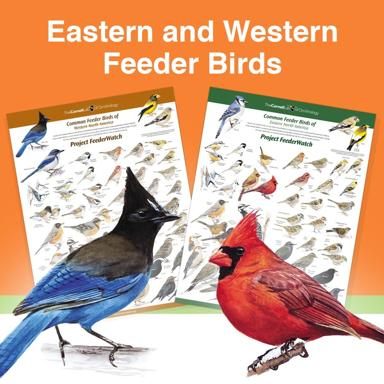How can I differentiate between Eastern and Western feeder birds? One way to differentiate between Eastern and Western feeder birds is by looking at their colors, patterns, and physical features. Since the image displays two different bird posters, you can compare and contrast the birds' appearances to identify differences according to their geographic regions. Keep in mind that some species may overlap between Eastern and Western regions, sharing similar characteristics, but others will be unique to their specific region. What is the significance of having separate posters for Eastern and Western feeder birds? Having separate posters for Eastern and Western feeder birds allows bird enthusiasts and researchers to have a clear distinction between the species found in each region. These posters can serve as a visual guide for bird watchers or individuals who are interested in identifying and understanding the birds visiting their feeders. Each region has its unique bird species, and categorizing them according to their geographic distribution helps to better study, appreciate and conserve them. 